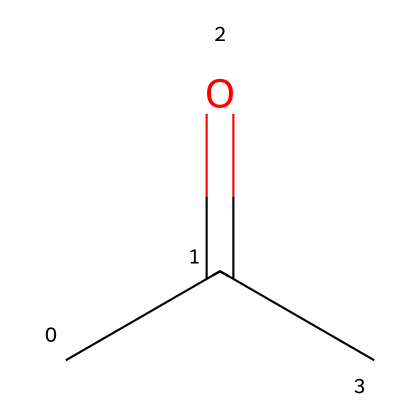How many carbon atoms are in acetone? The SMILES representation indicates there are three carbon atoms (C) since "C" appears three times in the structure.
Answer: three What functional group is present in acetone? Analyzing the structure, the presence of the "C(=O)" part indicates a carbonyl group, specifically a ketone since it is flanked by other carbon atoms, classifying it as acetone.
Answer: carbonyl What is the total number of hydrogen atoms in acetone? The structure shows that acetone has six hydrogen atoms (H) when you count all the hydrogen atoms bonded to the carbon atoms based on typical valency rules: each of the two outer carbons bonds to three hydrogens and the central carbon bonds to one hydrogen.
Answer: six What type of solvent is acetone classified as? Given its polar nature and ability to dissolve many organic compounds, acetone is classified as a polar aprotic solvent, which aids in its effectiveness as a sterilization agent.
Answer: polar aprotic How does the structure of acetone facilitate its effectiveness in sterilization solutions? The carbonyl group (C=O) in acetone increases its polarity, allowing it to interact with water and various organic contaminants, enhancing its effectiveness in dissolving and removing residues from cardiac equipment.
Answer: enhances dissolution What is the boiling point of acetone? Acetone has a boiling point of approximately 56 degrees Celsius, which is relatively low compared to other solvents, allowing it to evaporate quickly and be effective in sterilization.
Answer: 56 degrees Celsius Which common application of acetone relates to cardiology? Acetone is commonly used as a solvent in sterilization solutions for cleaning and disinfecting cardiac equipment, as its properties make it suitable for removing residues and microbial contaminants.
Answer: cleaning cardiac equipment 